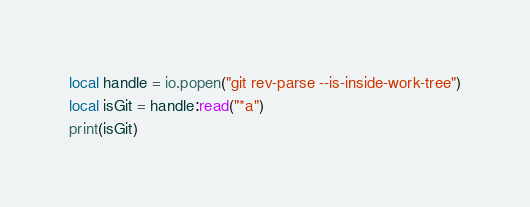Convert code to text. <code><loc_0><loc_0><loc_500><loc_500><_Lua_>local handle = io.popen("git rev-parse --is-inside-work-tree")
local isGit = handle:read("*a")
print(isGit)
</code> 